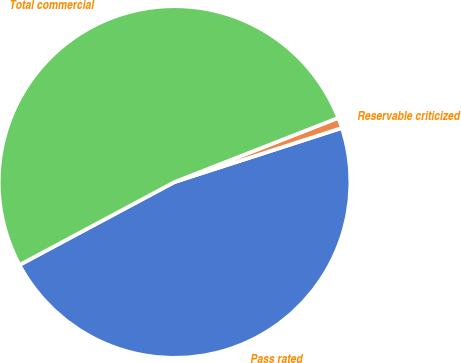Convert chart. <chart><loc_0><loc_0><loc_500><loc_500><pie_chart><fcel>Pass rated<fcel>Reservable criticized<fcel>Total commercial<nl><fcel>47.16%<fcel>0.97%<fcel>51.87%<nl></chart> 